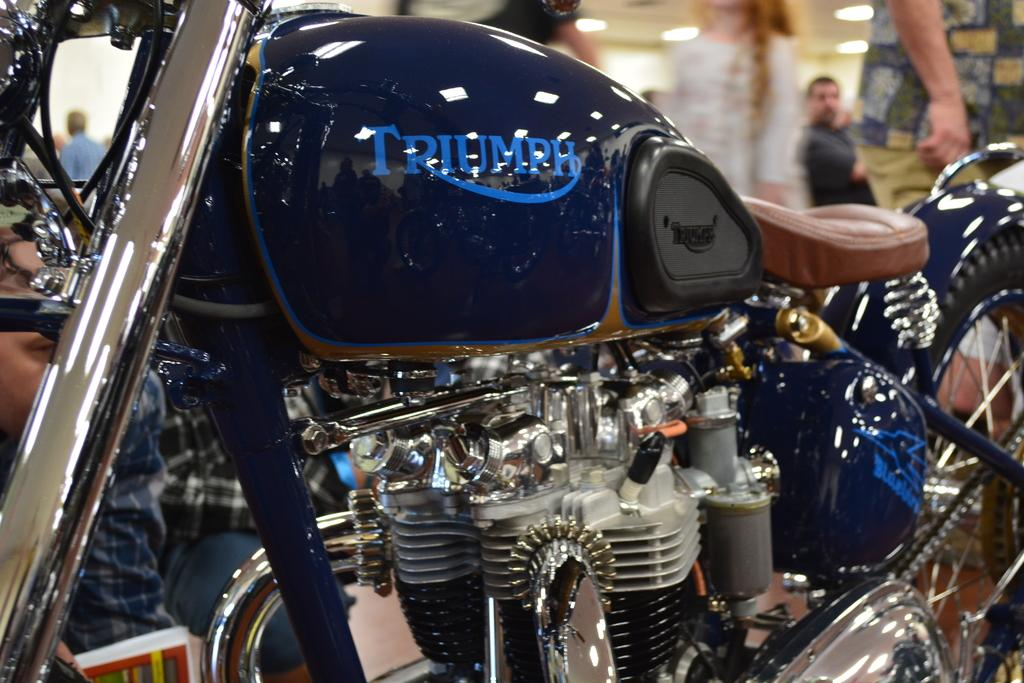What is the main subject of the image? The main subject of the image is a motorbike. Are there any people in the image? Yes, there are people behind the motorbike. What is the surface on which the motorbike is placed? There is a floor at the bottom of the image. What is located at the top of the image? There is a roof with lights at the top of the image. What type of table is being used to support the motorbike in the image? There is no table present in the image; the motorbike is on a floor. What kind of collar can be seen on the people behind the motorbike? There is no collar visible on the people in the image. 